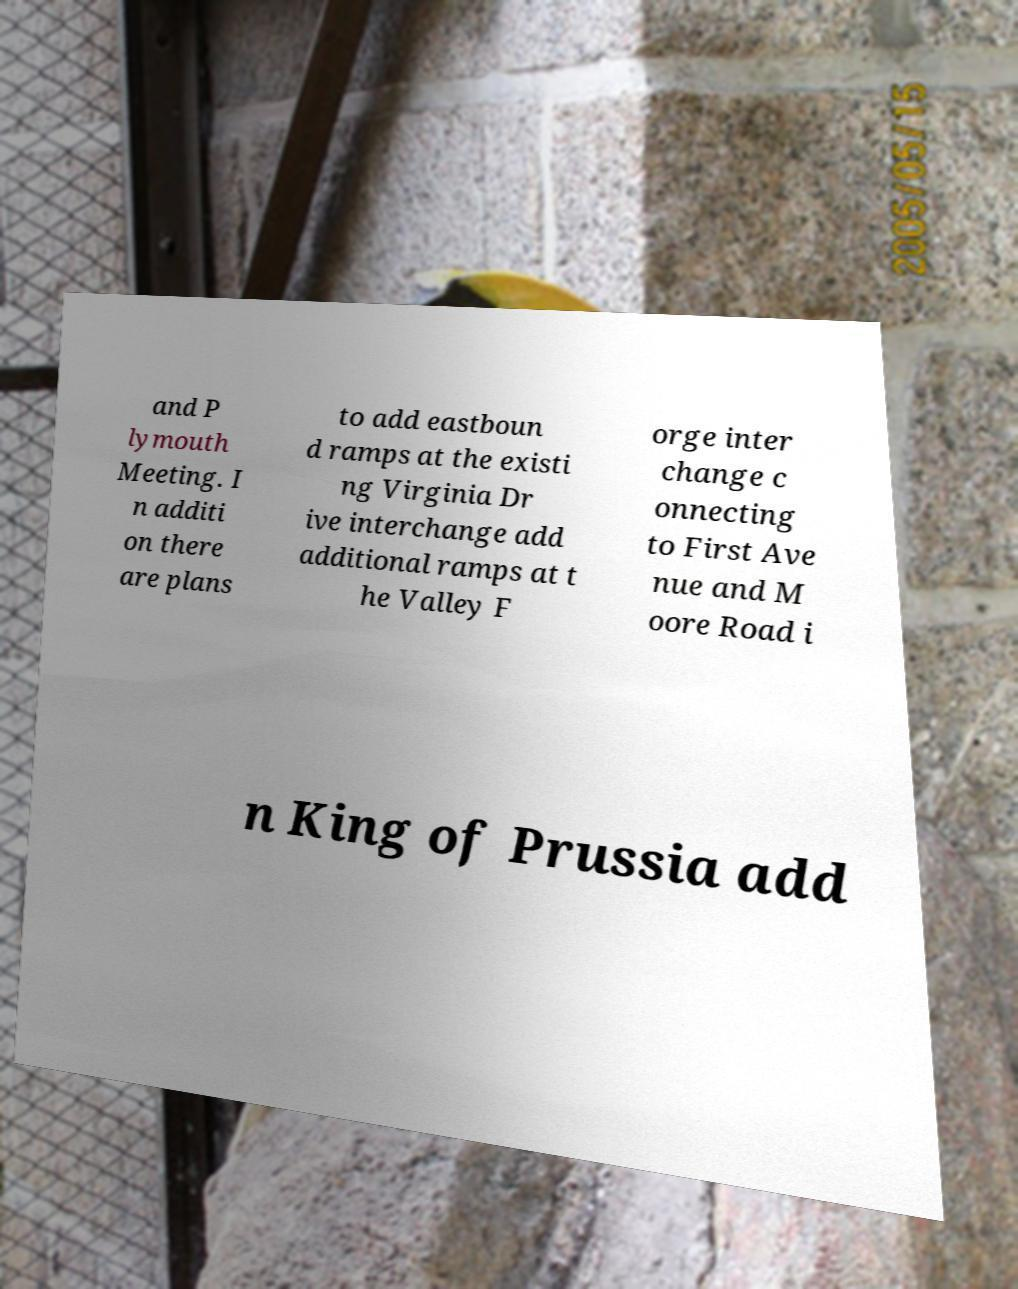Can you accurately transcribe the text from the provided image for me? and P lymouth Meeting. I n additi on there are plans to add eastboun d ramps at the existi ng Virginia Dr ive interchange add additional ramps at t he Valley F orge inter change c onnecting to First Ave nue and M oore Road i n King of Prussia add 